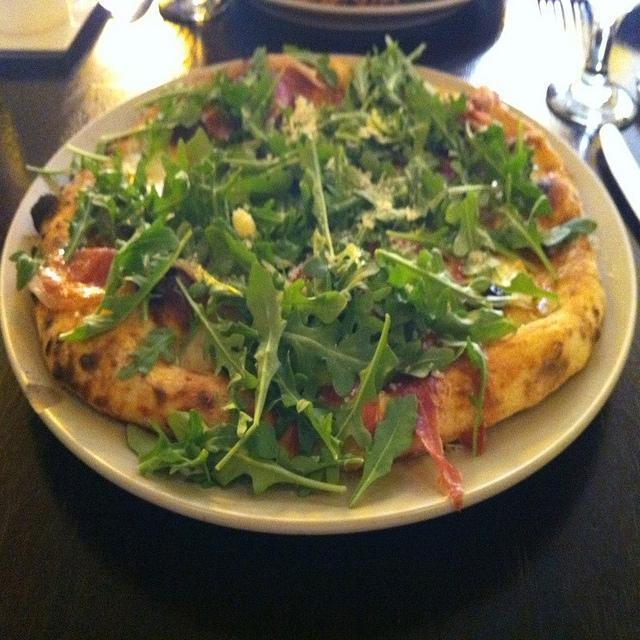How many spoons can be seen?
Give a very brief answer. 1. 